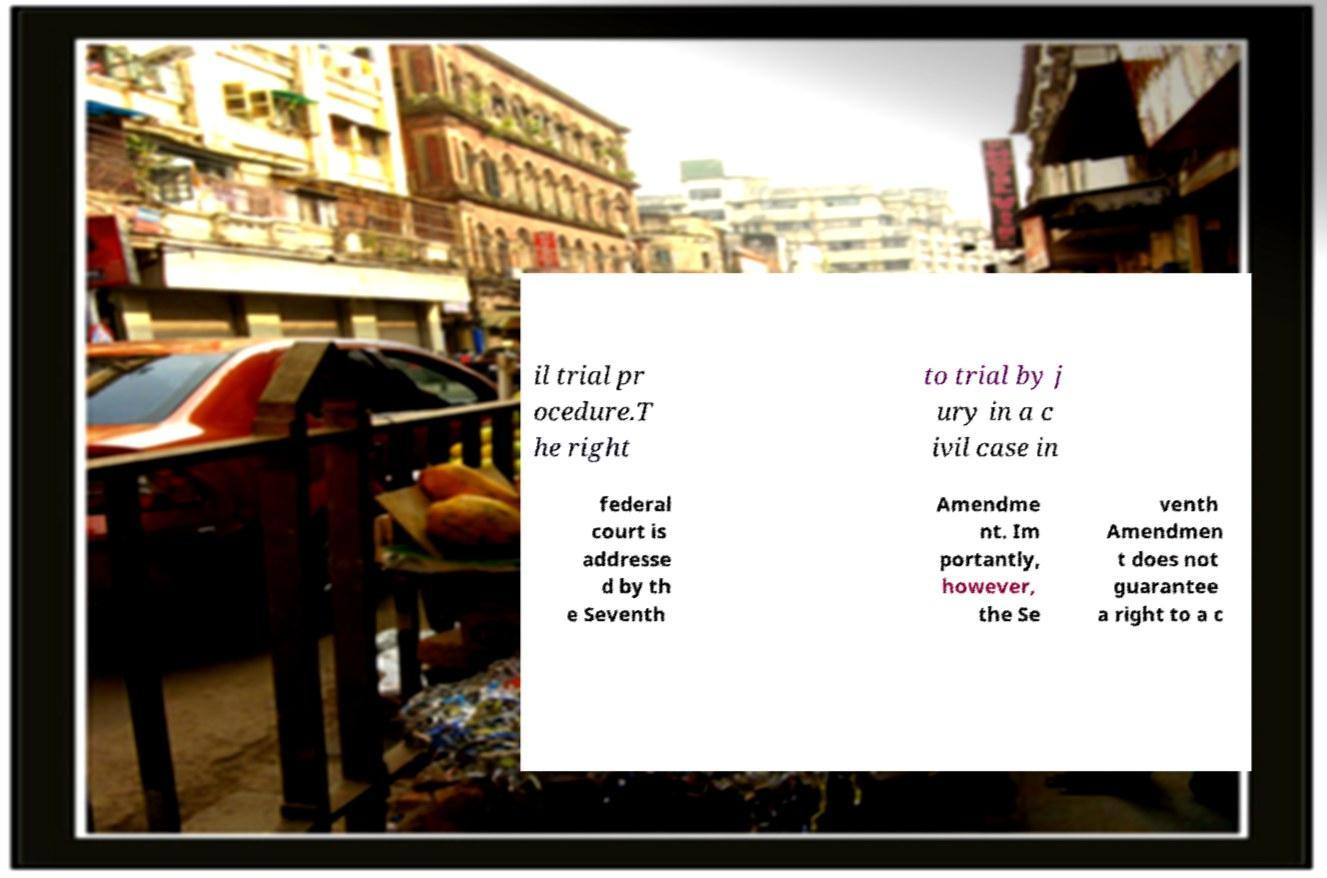There's text embedded in this image that I need extracted. Can you transcribe it verbatim? il trial pr ocedure.T he right to trial by j ury in a c ivil case in federal court is addresse d by th e Seventh Amendme nt. Im portantly, however, the Se venth Amendmen t does not guarantee a right to a c 